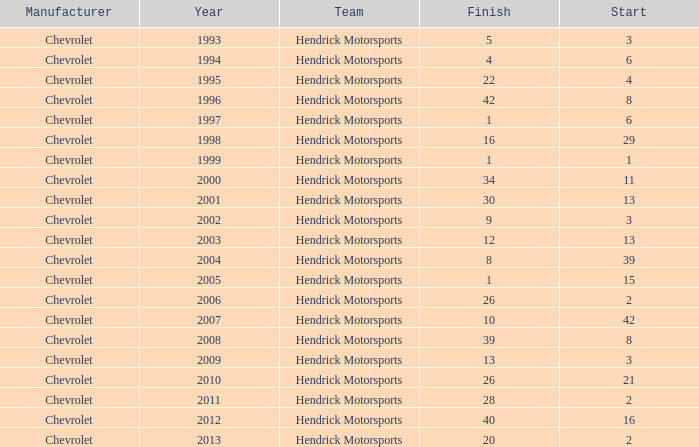What was Jeff's finish in 2011? 28.0. 